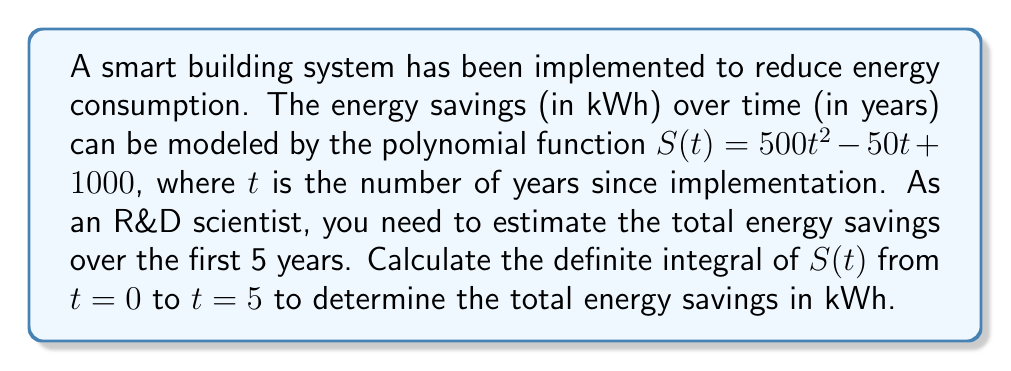Provide a solution to this math problem. To calculate the total energy savings over the first 5 years, we need to integrate the function $S(t)$ from $t=0$ to $t=5$. This will give us the area under the curve, which represents the cumulative energy savings.

1. The function is $S(t) = 500t^2 - 50t + 1000$

2. We need to find $\int_0^5 S(t) dt$

3. Integrate each term:
   $$\int_0^5 (500t^2 - 50t + 1000) dt = \left[\frac{500t^3}{3} - \frac{50t^2}{2} + 1000t\right]_0^5$$

4. Evaluate the indefinite integral at the upper and lower bounds:
   At $t=5$: $\frac{500(5^3)}{3} - \frac{50(5^2)}{2} + 1000(5) = 20833.33 - 625 + 5000 = 25208.33$
   At $t=0$: $\frac{500(0^3)}{3} - \frac{50(0^2)}{2} + 1000(0) = 0$

5. Subtract the lower bound result from the upper bound result:
   $25208.33 - 0 = 25208.33$

Therefore, the total energy savings over the first 5 years is approximately 25,208.33 kWh.
Answer: 25,208.33 kWh 